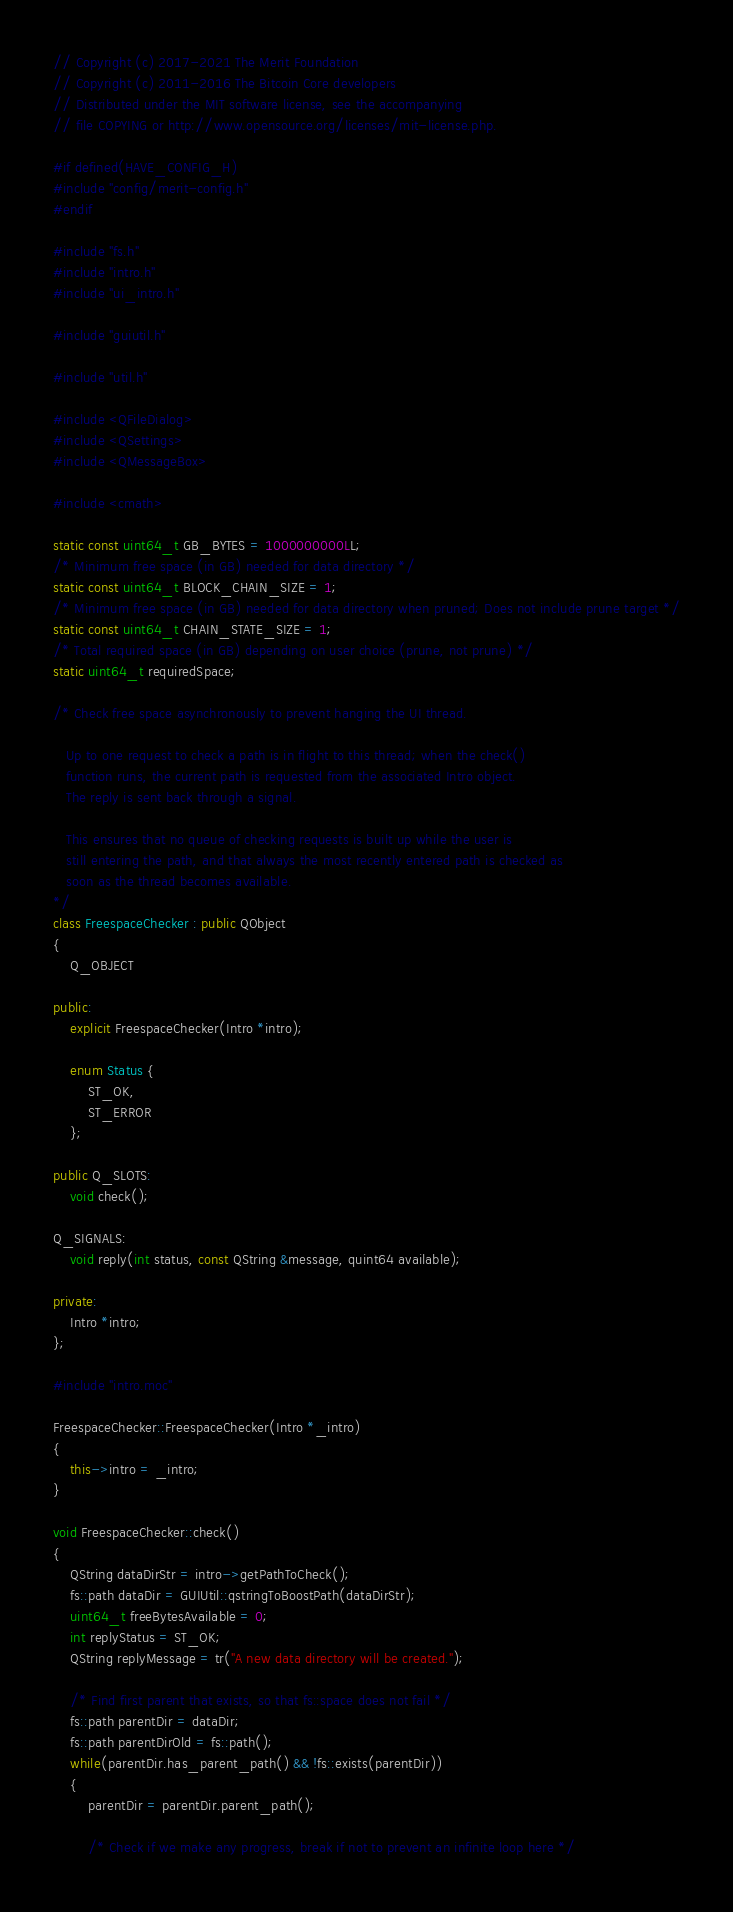<code> <loc_0><loc_0><loc_500><loc_500><_C++_>// Copyright (c) 2017-2021 The Merit Foundation
// Copyright (c) 2011-2016 The Bitcoin Core developers
// Distributed under the MIT software license, see the accompanying
// file COPYING or http://www.opensource.org/licenses/mit-license.php.

#if defined(HAVE_CONFIG_H)
#include "config/merit-config.h"
#endif

#include "fs.h"
#include "intro.h"
#include "ui_intro.h"

#include "guiutil.h"

#include "util.h"

#include <QFileDialog>
#include <QSettings>
#include <QMessageBox>

#include <cmath>

static const uint64_t GB_BYTES = 1000000000LL;
/* Minimum free space (in GB) needed for data directory */
static const uint64_t BLOCK_CHAIN_SIZE = 1;
/* Minimum free space (in GB) needed for data directory when pruned; Does not include prune target */
static const uint64_t CHAIN_STATE_SIZE = 1;
/* Total required space (in GB) depending on user choice (prune, not prune) */
static uint64_t requiredSpace;

/* Check free space asynchronously to prevent hanging the UI thread.

   Up to one request to check a path is in flight to this thread; when the check()
   function runs, the current path is requested from the associated Intro object.
   The reply is sent back through a signal.

   This ensures that no queue of checking requests is built up while the user is
   still entering the path, and that always the most recently entered path is checked as
   soon as the thread becomes available.
*/
class FreespaceChecker : public QObject
{
    Q_OBJECT

public:
    explicit FreespaceChecker(Intro *intro);

    enum Status {
        ST_OK,
        ST_ERROR
    };

public Q_SLOTS:
    void check();

Q_SIGNALS:
    void reply(int status, const QString &message, quint64 available);

private:
    Intro *intro;
};

#include "intro.moc"

FreespaceChecker::FreespaceChecker(Intro *_intro)
{
    this->intro = _intro;
}

void FreespaceChecker::check()
{
    QString dataDirStr = intro->getPathToCheck();
    fs::path dataDir = GUIUtil::qstringToBoostPath(dataDirStr);
    uint64_t freeBytesAvailable = 0;
    int replyStatus = ST_OK;
    QString replyMessage = tr("A new data directory will be created.");

    /* Find first parent that exists, so that fs::space does not fail */
    fs::path parentDir = dataDir;
    fs::path parentDirOld = fs::path();
    while(parentDir.has_parent_path() && !fs::exists(parentDir))
    {
        parentDir = parentDir.parent_path();

        /* Check if we make any progress, break if not to prevent an infinite loop here */</code> 